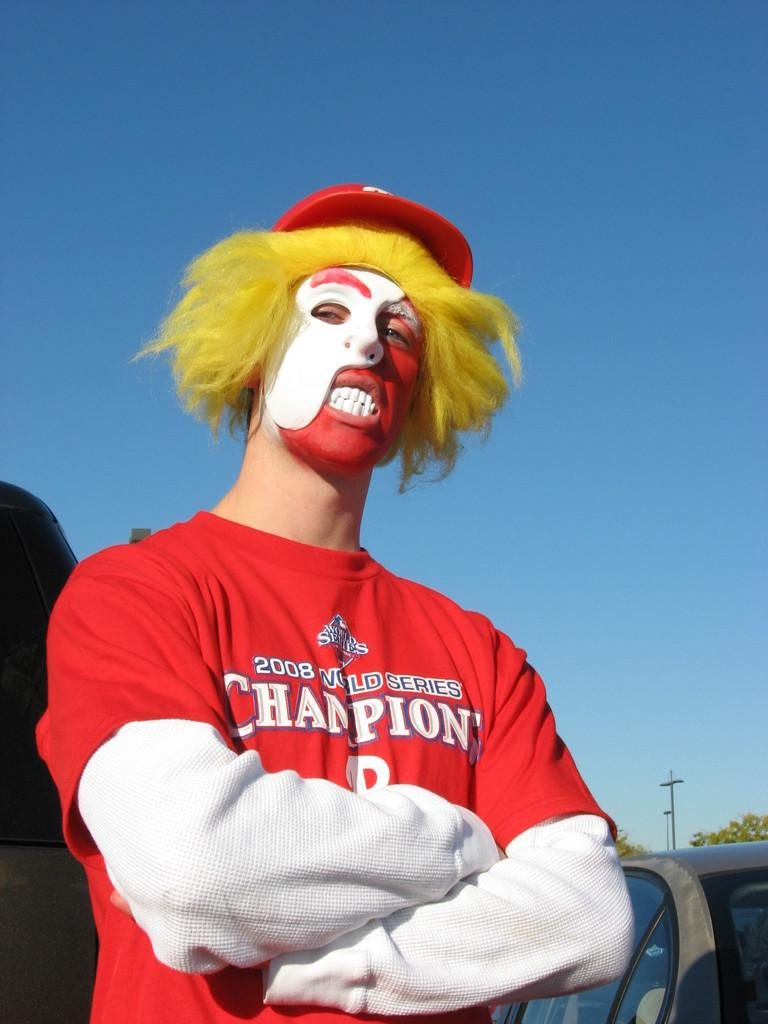<image>
Present a compact description of the photo's key features. A man in a 2008 world series champion shirt wears a white mask. 